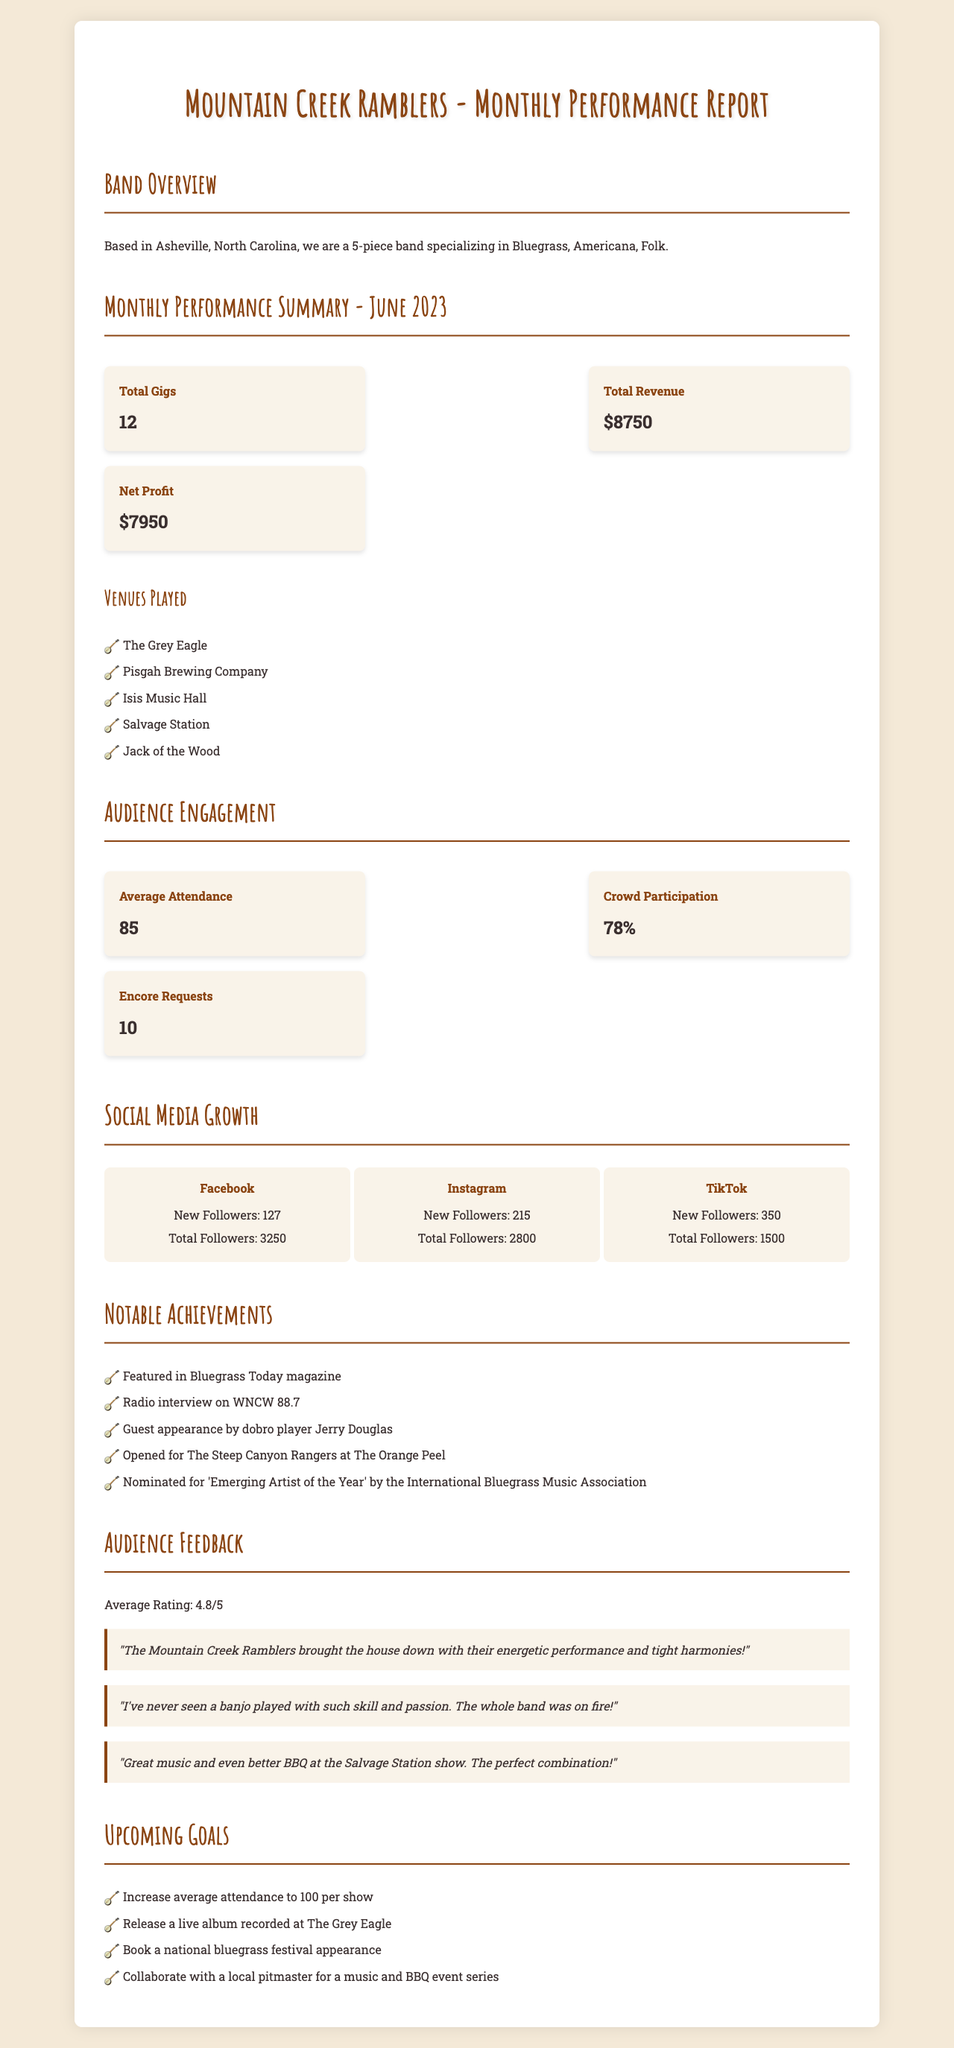What is the name of the band? The name of the band is provided under band info section.
Answer: Mountain Creek Ramblers How many total gigs were performed in June 2023? The total number of gigs performed is listed directly in the performance summary.
Answer: 12 What was the total revenue for June 2023? The total revenue is a key financial metric presented in the financial data section.
Answer: $8750 What was the net profit for the month? The net profit is specifically mentioned in the financial data breakdown.
Answer: $7950 What is the average attendance at the gigs? Average attendance is an audience engagement metric given in the document.
Answer: 85 How many new Instagram followers were gained? The new followers for each social media platform are detailed in the social media growth section.
Answer: 215 What was the most engaging Facebook post? The most engaging post on Facebook is highlighted in the social media growth section.
Answer: Behind-the-scenes jam session with Billy Strings What is the average rating from audience feedback? The average rating is an important metric found in the audience feedback section.
Answer: 4.8 What is one of the upcoming goals for the band? The upcoming goals are provided in the goals section of the report.
Answer: Increase average attendance to 100 per show What notable achievement did the band receive in June 2023? Notable achievements are listed, detailing specific recognitions each month.
Answer: Nominated for 'Emerging Artist of the Year' by the International Bluegrass Music Association 